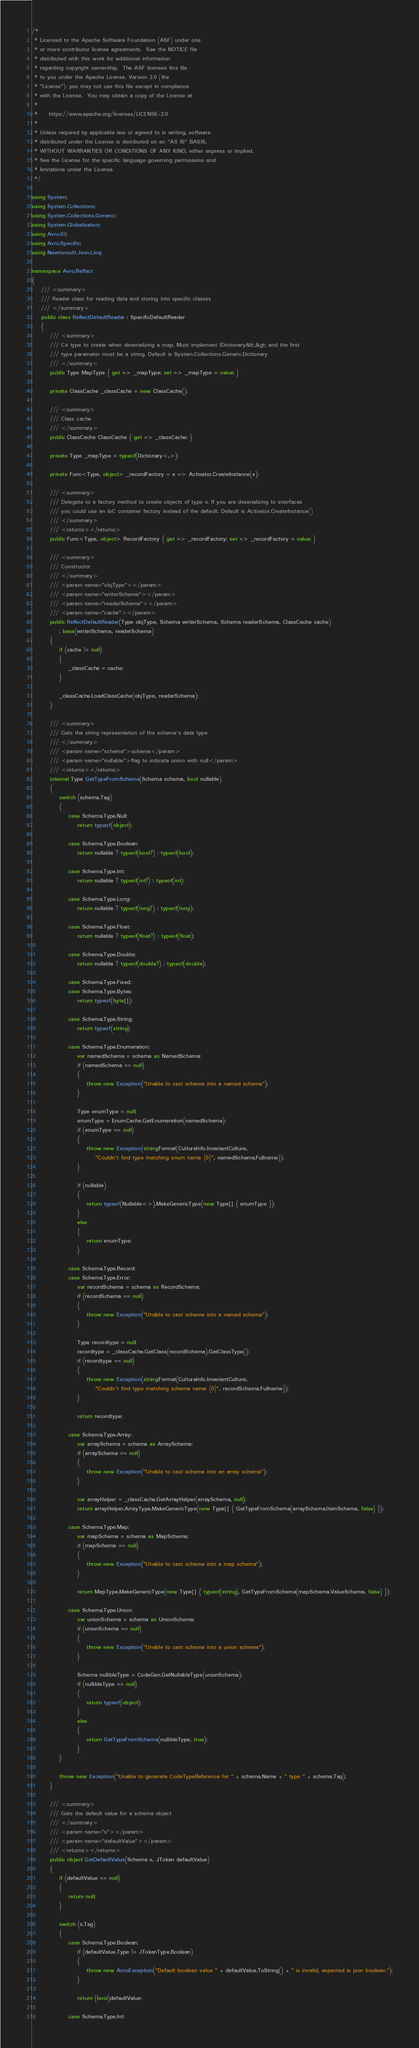<code> <loc_0><loc_0><loc_500><loc_500><_C#_>/*
 * Licensed to the Apache Software Foundation (ASF) under one
 * or more contributor license agreements.  See the NOTICE file
 * distributed with this work for additional information
 * regarding copyright ownership.  The ASF licenses this file
 * to you under the Apache License, Version 2.0 (the
 * "License"); you may not use this file except in compliance
 * with the License.  You may obtain a copy of the License at
 *
 *     https://www.apache.org/licenses/LICENSE-2.0
 *
 * Unless required by applicable law or agreed to in writing, software
 * distributed under the License is distributed on an "AS IS" BASIS,
 * WITHOUT WARRANTIES OR CONDITIONS OF ANY KIND, either express or implied.
 * See the License for the specific language governing permissions and
 * limitations under the License.
 */

using System;
using System.Collections;
using System.Collections.Generic;
using System.Globalization;
using Avro.IO;
using Avro.Specific;
using Newtonsoft.Json.Linq;

namespace Avro.Reflect
{
    /// <summary>
    /// Reader class for reading data and storing into specific classes
    /// </summary>
    public class ReflectDefaultReader : SpecificDefaultReader
    {
        /// <summary>
        /// C# type to create when deserializing a map. Must implement IDictionary&lt;,&gt; and the first
        /// type parameter must be a string. Default is System.Collections.Generic.Dictionary
        /// </summary>
        public Type MapType { get => _mapType; set => _mapType = value; }

        private ClassCache _classCache = new ClassCache();

        /// <summary>
        /// Class cache
        /// </summary>
        public ClassCache ClassCache { get => _classCache; }

        private Type _mapType = typeof(Dictionary<,>);

        private Func<Type, object> _recordFactory = x => Activator.CreateInstance(x);

        /// <summary>
        /// Delegate to a factory method to create objects of type x. If you are deserializing to interfaces
        /// you could use an IoC container factory instead of the default. Default is Activator.CreateInstance()
        /// </summary>
        /// <returns></returns>
        public Func<Type, object> RecordFactory { get => _recordFactory; set => _recordFactory = value; }

        /// <summary>
        /// Constructor
        /// </summary>
        /// <param name="objType"></param>
        /// <param name="writerSchema"></param>
        /// <param name="readerSchema"></param>
        /// <param name="cache"></param>
        public ReflectDefaultReader(Type objType, Schema writerSchema, Schema readerSchema, ClassCache cache)
            : base(writerSchema, readerSchema)
        {
            if (cache != null)
            {
                _classCache = cache;
            }

            _classCache.LoadClassCache(objType, readerSchema);
        }

        /// <summary>
        /// Gets the string representation of the schema's data type
        /// </summary>
        /// <param name="schema">schema</param>
        /// <param name="nullable">flag to indicate union with null</param>
        /// <returns></returns>
        internal Type GetTypeFromSchema(Schema schema, bool nullable)
        {
            switch (schema.Tag)
            {
                case Schema.Type.Null:
                    return typeof(object);

                case Schema.Type.Boolean:
                    return nullable ? typeof(bool?) : typeof(bool);

                case Schema.Type.Int:
                    return nullable ? typeof(int?) : typeof(int);

                case Schema.Type.Long:
                    return nullable ? typeof(long?) : typeof(long);

                case Schema.Type.Float:
                    return nullable ? typeof(float?) : typeof(float);

                case Schema.Type.Double:
                    return nullable ? typeof(double?) : typeof(double);

                case Schema.Type.Fixed:
                case Schema.Type.Bytes:
                    return typeof(byte[]);

                case Schema.Type.String:
                    return typeof(string);

                case Schema.Type.Enumeration:
                    var namedSchema = schema as NamedSchema;
                    if (namedSchema == null)
                    {
                        throw new Exception("Unable to cast schema into a named schema");
                    }

                    Type enumType = null;
                    enumType = EnumCache.GetEnumeration(namedSchema);
                    if (enumType == null)
                    {
                        throw new Exception(string.Format(CultureInfo.InvariantCulture,
                            "Couldn't find type matching enum name {0}", namedSchema.Fullname));
                    }

                    if (nullable)
                    {
                        return typeof(Nullable<>).MakeGenericType(new Type[] { enumType });
                    }
                    else
                    {
                        return enumType;
                    }

                case Schema.Type.Record:
                case Schema.Type.Error:
                    var recordSchema = schema as RecordSchema;
                    if (recordSchema == null)
                    {
                        throw new Exception("Unable to cast schema into a named schema");
                    }

                    Type recordtype = null;
                    recordtype = _classCache.GetClass(recordSchema).GetClassType();
                    if (recordtype == null)
                    {
                        throw new Exception(string.Format(CultureInfo.InvariantCulture,
                            "Couldn't find type matching schema name {0}", recordSchema.Fullname));
                    }

                    return recordtype;

                case Schema.Type.Array:
                    var arraySchema = schema as ArraySchema;
                    if (arraySchema == null)
                    {
                        throw new Exception("Unable to cast schema into an array schema");
                    }

                    var arrayHelper = _classCache.GetArrayHelper(arraySchema, null);
                    return arrayHelper.ArrayType.MakeGenericType(new Type[] { GetTypeFromSchema(arraySchema.ItemSchema, false) });

                case Schema.Type.Map:
                    var mapSchema = schema as MapSchema;
                    if (mapSchema == null)
                    {
                        throw new Exception("Unable to cast schema into a map schema");
                    }

                    return MapType.MakeGenericType(new Type[] { typeof(string), GetTypeFromSchema(mapSchema.ValueSchema, false) });

                case Schema.Type.Union:
                    var unionSchema = schema as UnionSchema;
                    if (unionSchema == null)
                    {
                        throw new Exception("Unable to cast schema into a union schema");
                    }

                    Schema nullibleType = CodeGen.GetNullableType(unionSchema);
                    if (nullibleType == null)
                    {
                        return typeof(object);
                    }
                    else
                    {
                        return GetTypeFromSchema(nullibleType, true);
                    }
            }

            throw new Exception("Unable to generate CodeTypeReference for " + schema.Name + " type " + schema.Tag);
        }

        /// <summary>
        /// Gets the default value for a schema object
        /// </summary>
        /// <param name="s"></param>
        /// <param name="defaultValue"></param>
        /// <returns></returns>
        public object GetDefaultValue(Schema s, JToken defaultValue)
        {
            if (defaultValue == null)
            {
                return null;
            }

            switch (s.Tag)
            {
                case Schema.Type.Boolean:
                    if (defaultValue.Type != JTokenType.Boolean)
                    {
                        throw new AvroException("Default boolean value " + defaultValue.ToString() + " is invalid, expected is json boolean.");
                    }

                    return (bool)defaultValue;

                case Schema.Type.Int:</code> 